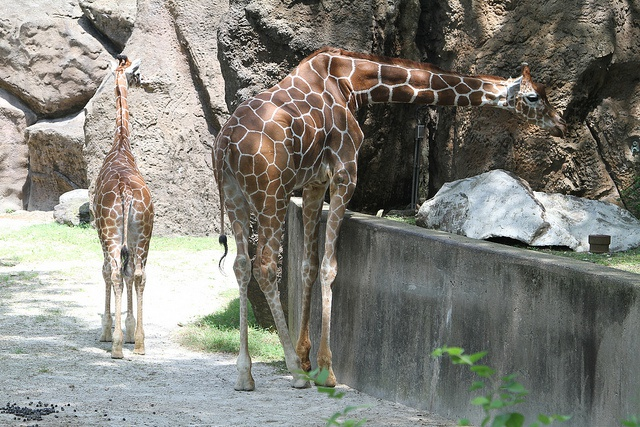Describe the objects in this image and their specific colors. I can see giraffe in lightgray, gray, black, maroon, and darkgray tones and giraffe in lightgray, darkgray, and gray tones in this image. 